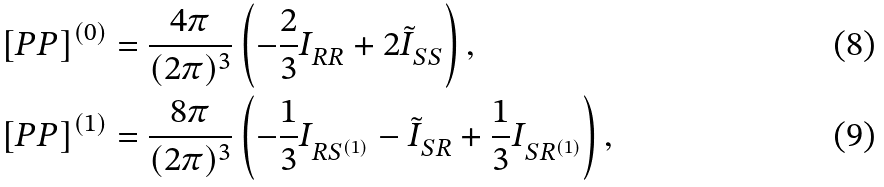Convert formula to latex. <formula><loc_0><loc_0><loc_500><loc_500>& \left [ P P \right ] ^ { ( 0 ) } = \frac { 4 \pi } { ( 2 \pi ) ^ { 3 } } \left ( - \frac { 2 } { 3 } I ^ { \ } _ { R R } + 2 \tilde { I } ^ { \ } _ { S S } \right ) , \\ & \left [ P P \right ] ^ { ( 1 ) } = \frac { 8 \pi } { ( 2 \pi ) ^ { 3 } } \left ( - \frac { 1 } { 3 } I ^ { \ } _ { R S ^ { ( 1 ) } } - \tilde { I } ^ { \ } _ { S R } + \frac { 1 } { 3 } I ^ { \ } _ { S R ^ { ( 1 ) } } \right ) ,</formula> 